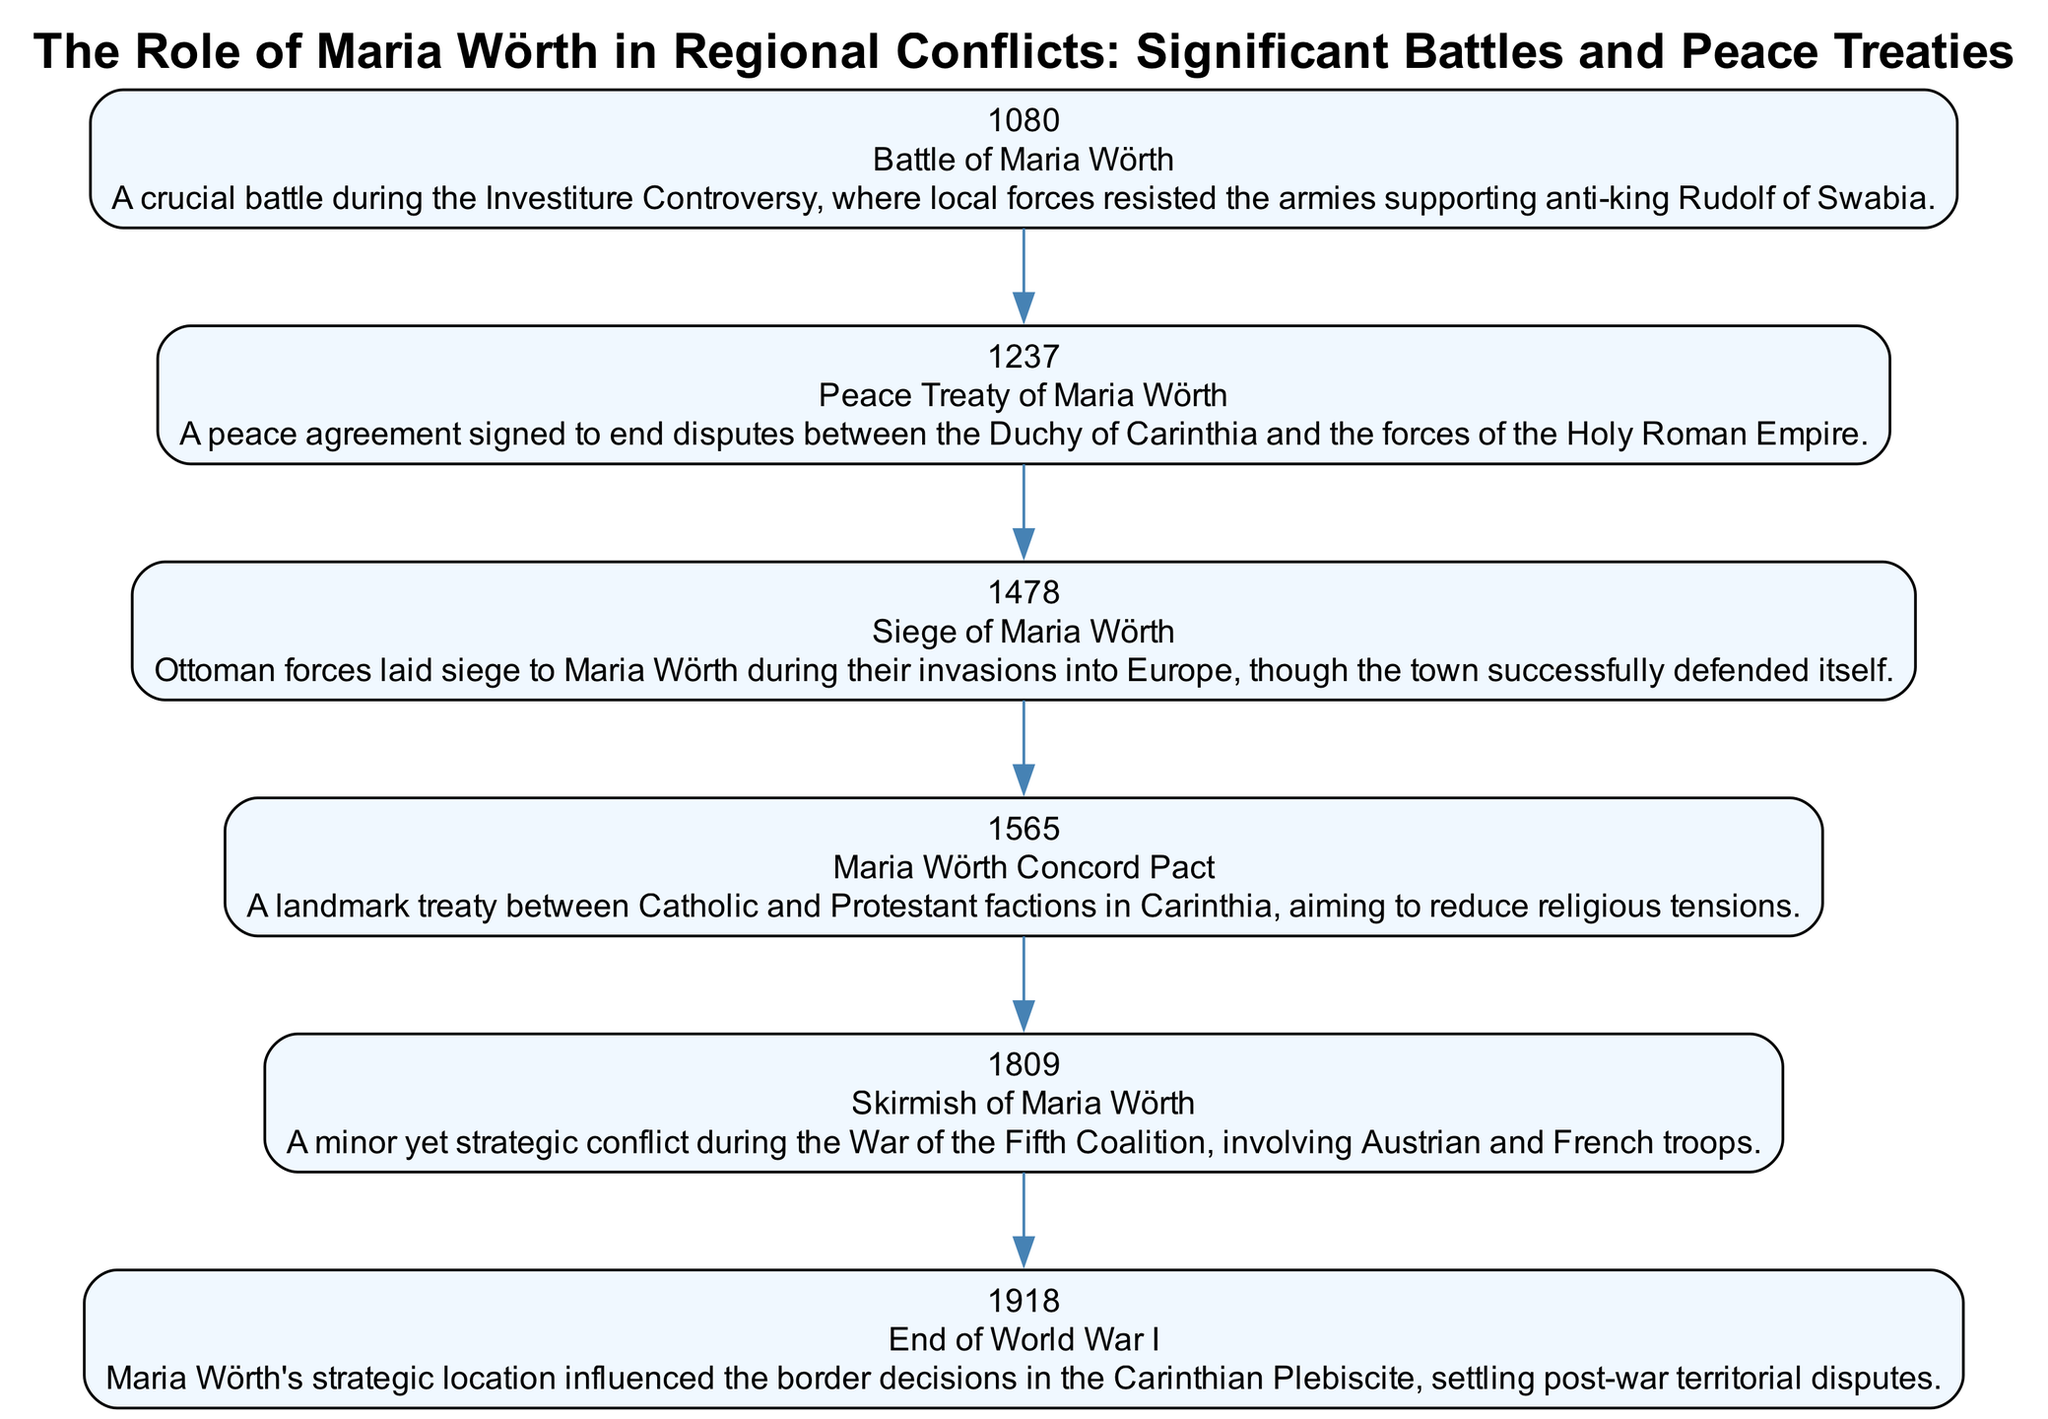What was the first significant event in the diagram? The first event listed in the diagram is the "Battle of Maria Wörth" in 1080, as indicated by its placement as the first node in the chronological sequence.
Answer: Battle of Maria Wörth How many events are listed in the diagram? Counting the individual events shown in the diagram, there are a total of six events, from the Battle of Maria Wörth in 1080 to the end of World War I in 1918.
Answer: 6 What year did the Siege of Maria Wörth occur? The diagram specifies that the "Siege of Maria Wörth" took place in 1478, as indicated in the event's description.
Answer: 1478 Which event immediately follows the Peace Treaty of Maria Wörth? The event that follows the "Peace Treaty of Maria Wörth" is the "Siege of Maria Wörth" in 1478, as this shows the chronological flow from one event to the next.
Answer: Siege of Maria Wörth What were the main factions involved in the 1565 event? The "Maria Wörth Concord Pact" in 1565 involved Catholic and Protestant factions in Carinthia, as described in its event information.
Answer: Catholic and Protestant How did the location of Maria Wörth influence post-World War I decisions? Apparently, Maria Wörth's strategic location played a crucial role in influencing border decisions during the Carinthian Plebiscite after World War I, as described.
Answer: Border decisions Which event signifies a peace agreement? The "Peace Treaty of Maria Wörth" in 1237 signifies a peace agreement intended to resolve conflicts between the Duchy of Carinthia and the Holy Roman Empire.
Answer: Peace Treaty of Maria Wörth What type of conflict was the Skirmish of Maria Wörth? The diagram identifies the "Skirmish of Maria Wörth" in 1809 as a minor but strategic conflict occurring during the War of the Fifth Coalition.
Answer: Minor yet strategic conflict What was the main purpose of the Maria Wörth Concord Pact? The Maria Wörth Concord Pact aimed to reduce religious tensions between Catholic and Protestant factions, as stated in the event description from 1565.
Answer: Reduce religious tensions 